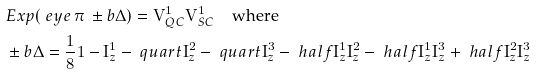Convert formula to latex. <formula><loc_0><loc_0><loc_500><loc_500>\, & E x p ( \ e y e \, \pi \, \pm b \Delta ) = \mathbf V _ { Q C } ^ { 1 } \mathbf V _ { S C } ^ { 1 } \quad \text {where} \\ & \pm b \Delta = \frac { 1 } { 8 } \mathbf 1 - \mathbf I _ { z } ^ { 1 } - \ q u a r t \mathbf I _ { z } ^ { 2 } - \ q u a r t \mathbf I _ { z } ^ { 3 } - \ h a l f \mathbf I _ { z } ^ { 1 } \mathbf I _ { z } ^ { 2 } - \ h a l f \mathbf I _ { z } ^ { 1 } \mathbf I _ { z } ^ { 3 } + \ h a l f \mathbf I _ { z } ^ { 2 } \mathbf I _ { z } ^ { 3 }</formula> 